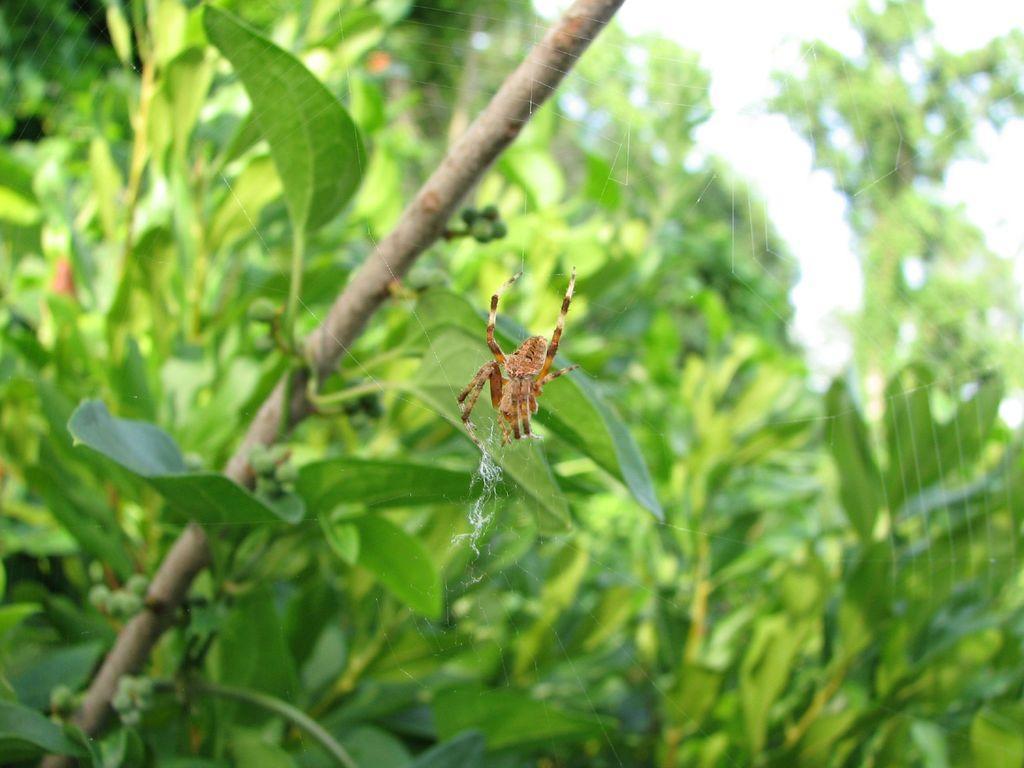Please provide a concise description of this image. In this image there is a spider on the web. Background there are plants having leaves. Right top there is sky. 